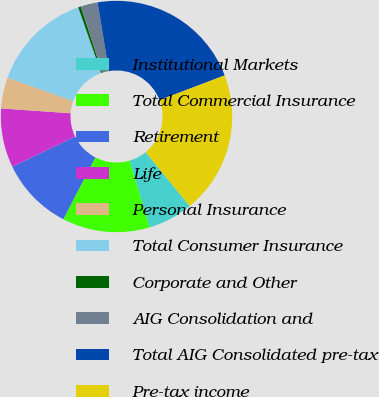<chart> <loc_0><loc_0><loc_500><loc_500><pie_chart><fcel>Institutional Markets<fcel>Total Commercial Insurance<fcel>Retirement<fcel>Life<fcel>Personal Insurance<fcel>Total Consumer Insurance<fcel>Corporate and Other<fcel>AIG Consolidation and<fcel>Total AIG Consolidated pre-tax<fcel>Pre-tax income<nl><fcel>6.3%<fcel>12.21%<fcel>10.24%<fcel>8.27%<fcel>4.33%<fcel>14.18%<fcel>0.39%<fcel>2.36%<fcel>21.85%<fcel>19.88%<nl></chart> 